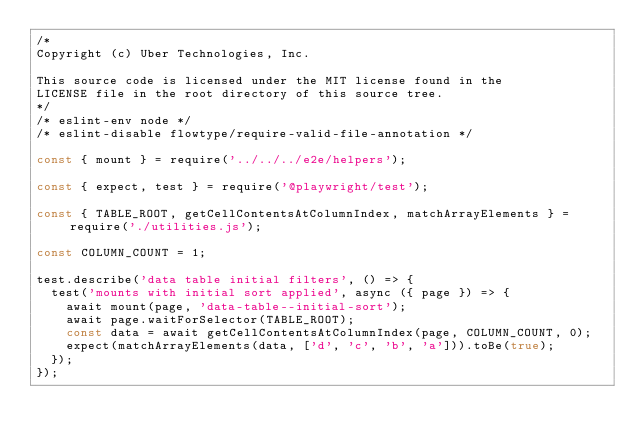<code> <loc_0><loc_0><loc_500><loc_500><_JavaScript_>/*
Copyright (c) Uber Technologies, Inc.

This source code is licensed under the MIT license found in the
LICENSE file in the root directory of this source tree.
*/
/* eslint-env node */
/* eslint-disable flowtype/require-valid-file-annotation */

const { mount } = require('../../../e2e/helpers');

const { expect, test } = require('@playwright/test');

const { TABLE_ROOT, getCellContentsAtColumnIndex, matchArrayElements } = require('./utilities.js');

const COLUMN_COUNT = 1;

test.describe('data table initial filters', () => {
  test('mounts with initial sort applied', async ({ page }) => {
    await mount(page, 'data-table--initial-sort');
    await page.waitForSelector(TABLE_ROOT);
    const data = await getCellContentsAtColumnIndex(page, COLUMN_COUNT, 0);
    expect(matchArrayElements(data, ['d', 'c', 'b', 'a'])).toBe(true);
  });
});
</code> 